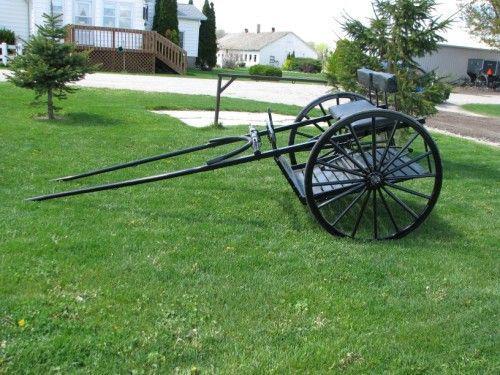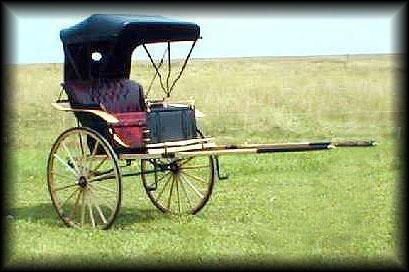The first image is the image on the left, the second image is the image on the right. For the images displayed, is the sentence "In one image, the 'handles' of the wagon are tilted to the ground." factually correct? Answer yes or no. Yes. The first image is the image on the left, the second image is the image on the right. Evaluate the accuracy of this statement regarding the images: "The front end of one of the carts is on the ground.". Is it true? Answer yes or no. Yes. 